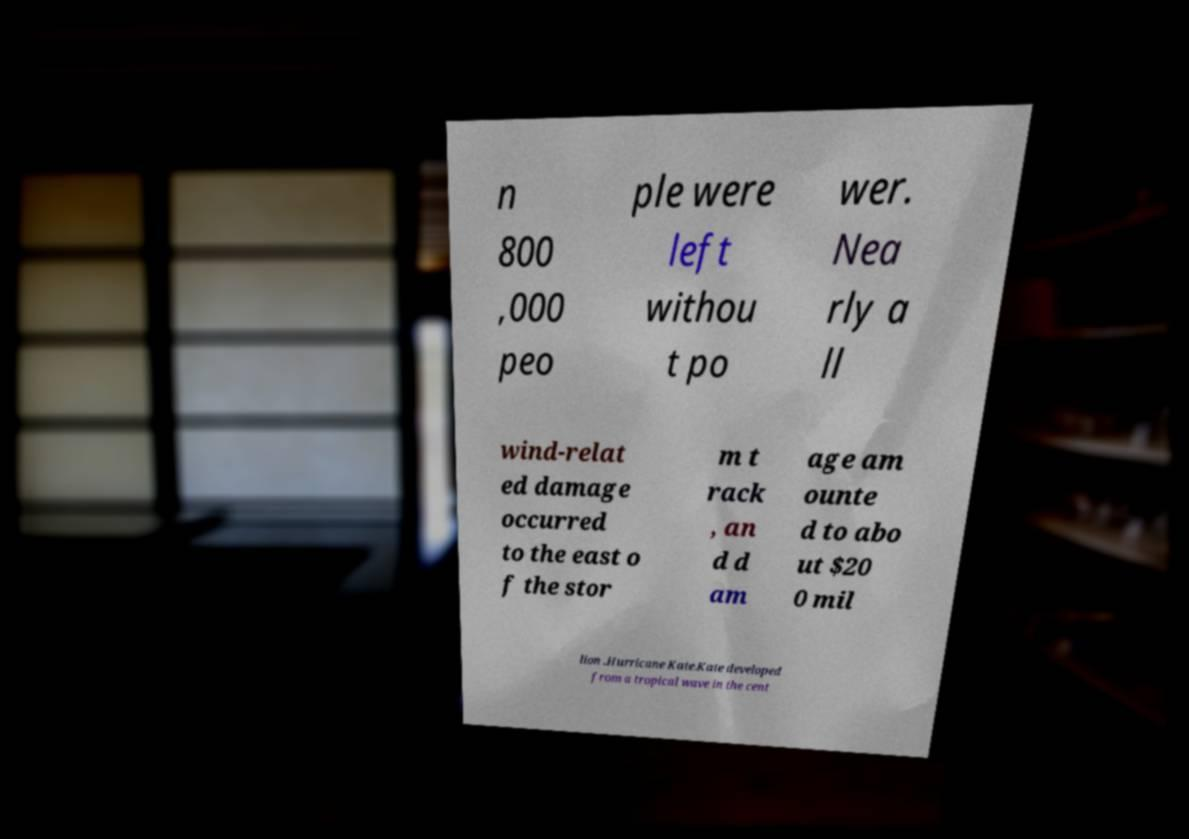Could you extract and type out the text from this image? n 800 ,000 peo ple were left withou t po wer. Nea rly a ll wind-relat ed damage occurred to the east o f the stor m t rack , an d d am age am ounte d to abo ut $20 0 mil lion .Hurricane Kate.Kate developed from a tropical wave in the cent 